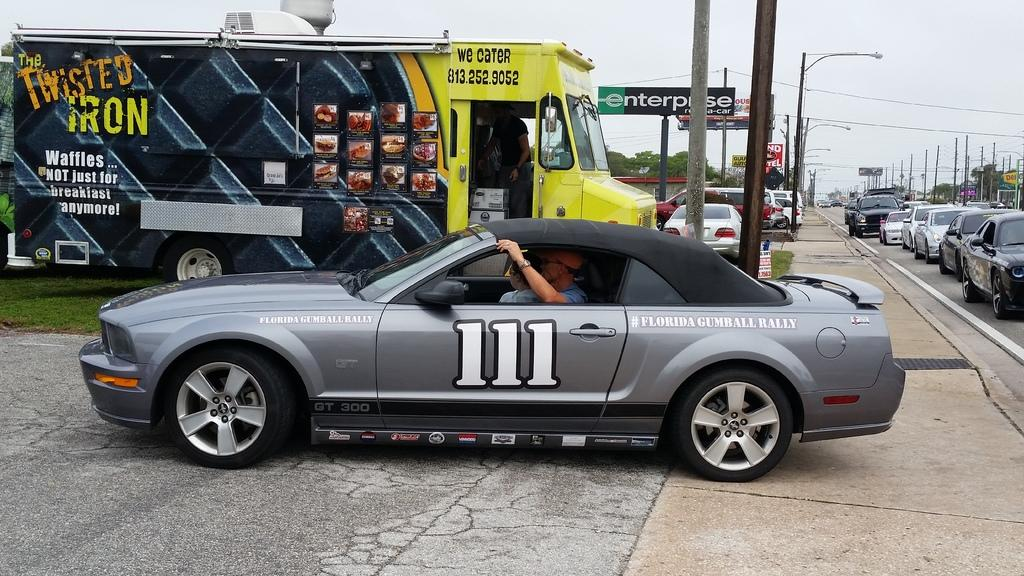What type of vehicle is in the image? There is a truck in the image. What else is present in the image besides the truck? There is a banner, cars, street lamps, trees, and the sky visible in the image. Can you describe the banner in the image? The banner is an additional element in the image, but its specific design or message is not mentioned in the provided facts. What type of lighting is present in the image? Street lamps are present in the image, providing illumination. What type of natural elements can be seen in the image? Trees are present in the image, representing natural elements. What type of gold can be seen on the feet of the people in the image? There are no people or gold present in the image; it features a truck, a banner, cars, street lamps, trees, and the sky. 